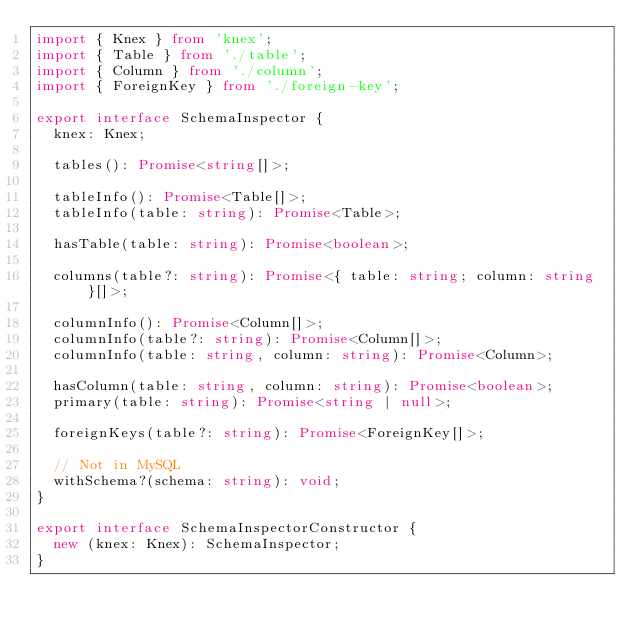<code> <loc_0><loc_0><loc_500><loc_500><_TypeScript_>import { Knex } from 'knex';
import { Table } from './table';
import { Column } from './column';
import { ForeignKey } from './foreign-key';

export interface SchemaInspector {
  knex: Knex;

  tables(): Promise<string[]>;

  tableInfo(): Promise<Table[]>;
  tableInfo(table: string): Promise<Table>;

  hasTable(table: string): Promise<boolean>;

  columns(table?: string): Promise<{ table: string; column: string }[]>;

  columnInfo(): Promise<Column[]>;
  columnInfo(table?: string): Promise<Column[]>;
  columnInfo(table: string, column: string): Promise<Column>;

  hasColumn(table: string, column: string): Promise<boolean>;
  primary(table: string): Promise<string | null>;

  foreignKeys(table?: string): Promise<ForeignKey[]>;

  // Not in MySQL
  withSchema?(schema: string): void;
}

export interface SchemaInspectorConstructor {
  new (knex: Knex): SchemaInspector;
}
</code> 